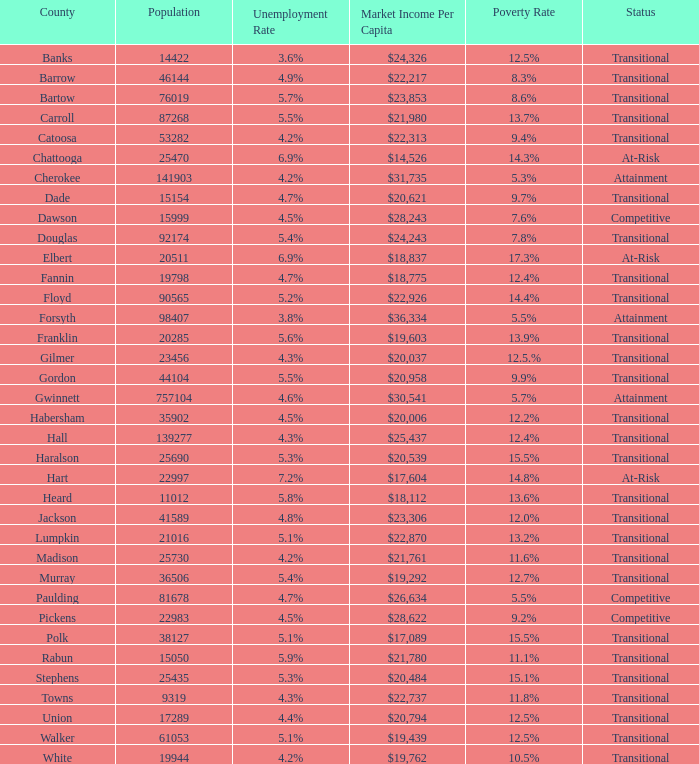How many status' are there with a population of 90565? 1.0. 